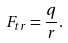Convert formula to latex. <formula><loc_0><loc_0><loc_500><loc_500>F _ { t r } = \frac { q } { r } .</formula> 